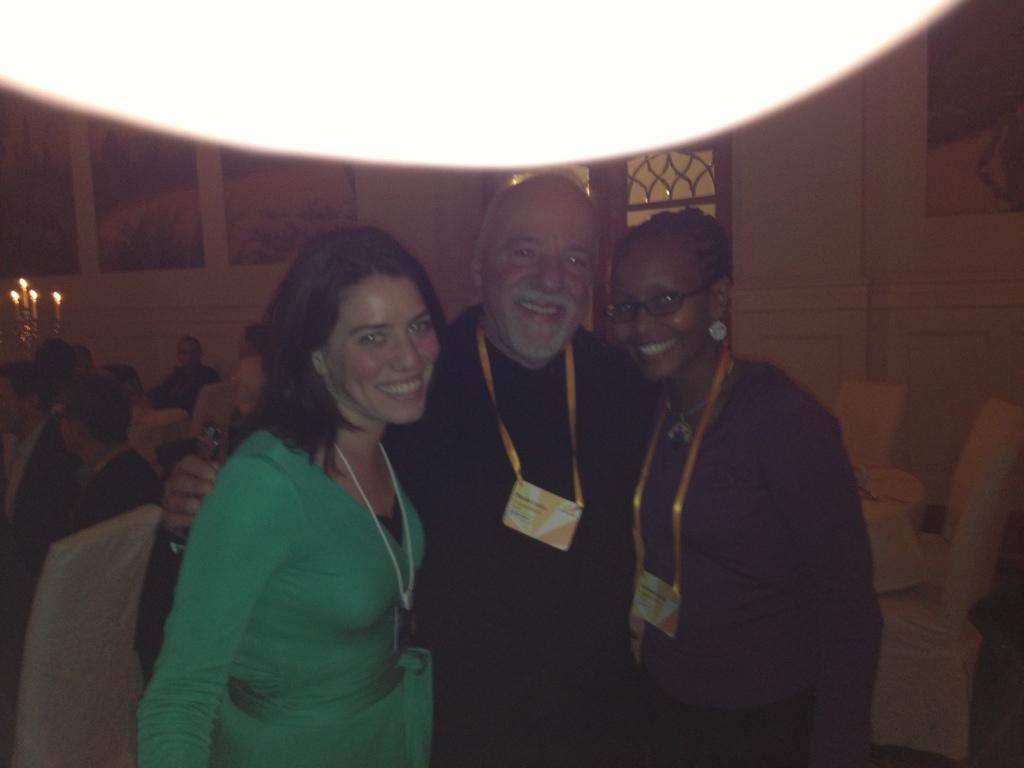How would you summarize this image in a sentence or two? In this image we can see one man and two women are standing and smiling. They are wearing tags around their neck. In the background, we can see people, chairs, candles, door and frames are attached on the wall. 